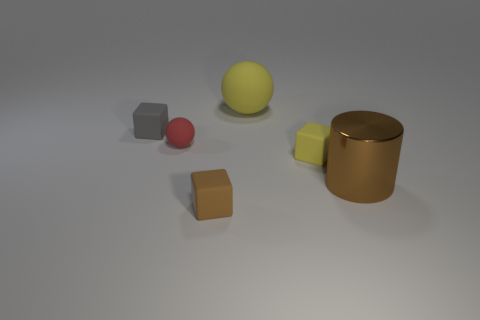What number of yellow rubber spheres have the same size as the brown matte block?
Provide a short and direct response. 0. Is the object that is in front of the large metallic object made of the same material as the cube that is left of the red matte sphere?
Your answer should be very brief. Yes. Are there more brown cubes than tiny shiny cubes?
Your answer should be very brief. Yes. Is there any other thing that is the same color as the big sphere?
Provide a succinct answer. Yes. Are the big brown object and the large yellow sphere made of the same material?
Your answer should be compact. No. Are there fewer blocks than big brown cylinders?
Make the answer very short. No. Does the tiny red thing have the same shape as the large yellow thing?
Provide a succinct answer. Yes. The small matte sphere is what color?
Offer a terse response. Red. What number of other objects are the same material as the gray cube?
Offer a very short reply. 4. What number of red things are tiny objects or matte balls?
Ensure brevity in your answer.  1. 